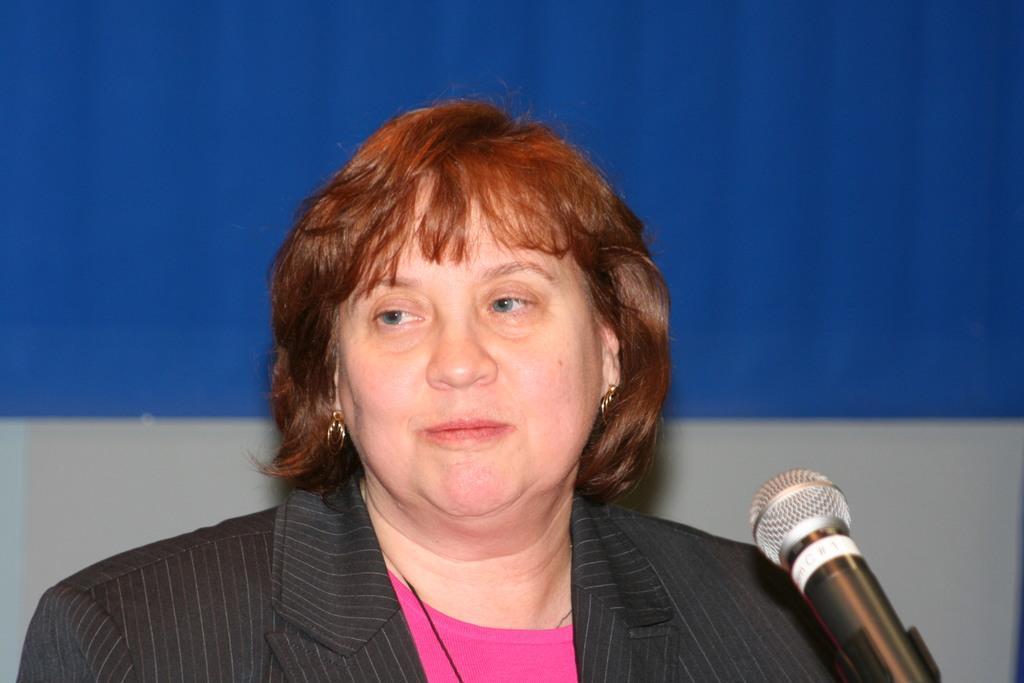In one or two sentences, can you explain what this image depicts? In this image I can see the black and grey color dress. I can see the mic in-front of the person. And there is a blue and ash color background. 